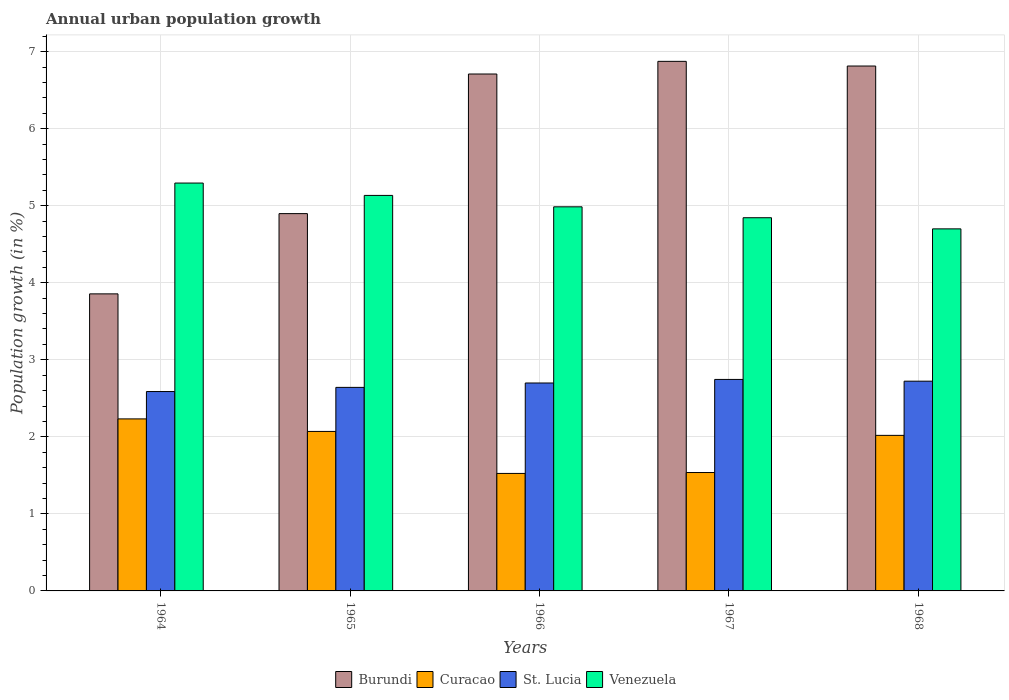Are the number of bars per tick equal to the number of legend labels?
Your answer should be very brief. Yes. Are the number of bars on each tick of the X-axis equal?
Offer a terse response. Yes. How many bars are there on the 1st tick from the left?
Ensure brevity in your answer.  4. What is the label of the 2nd group of bars from the left?
Make the answer very short. 1965. In how many cases, is the number of bars for a given year not equal to the number of legend labels?
Provide a short and direct response. 0. What is the percentage of urban population growth in Burundi in 1964?
Keep it short and to the point. 3.86. Across all years, what is the maximum percentage of urban population growth in Curacao?
Provide a succinct answer. 2.23. Across all years, what is the minimum percentage of urban population growth in St. Lucia?
Make the answer very short. 2.59. In which year was the percentage of urban population growth in St. Lucia maximum?
Ensure brevity in your answer.  1967. In which year was the percentage of urban population growth in Venezuela minimum?
Your response must be concise. 1968. What is the total percentage of urban population growth in Curacao in the graph?
Provide a short and direct response. 9.38. What is the difference between the percentage of urban population growth in Venezuela in 1964 and that in 1967?
Your response must be concise. 0.45. What is the difference between the percentage of urban population growth in Curacao in 1965 and the percentage of urban population growth in Venezuela in 1968?
Offer a very short reply. -2.63. What is the average percentage of urban population growth in Burundi per year?
Offer a terse response. 5.83. In the year 1965, what is the difference between the percentage of urban population growth in Burundi and percentage of urban population growth in Venezuela?
Make the answer very short. -0.24. In how many years, is the percentage of urban population growth in Curacao greater than 1.2 %?
Ensure brevity in your answer.  5. What is the ratio of the percentage of urban population growth in Curacao in 1964 to that in 1965?
Your answer should be compact. 1.08. What is the difference between the highest and the second highest percentage of urban population growth in St. Lucia?
Keep it short and to the point. 0.02. What is the difference between the highest and the lowest percentage of urban population growth in Curacao?
Your answer should be very brief. 0.71. What does the 2nd bar from the left in 1965 represents?
Provide a succinct answer. Curacao. What does the 3rd bar from the right in 1967 represents?
Keep it short and to the point. Curacao. Is it the case that in every year, the sum of the percentage of urban population growth in Burundi and percentage of urban population growth in Curacao is greater than the percentage of urban population growth in St. Lucia?
Provide a short and direct response. Yes. How many bars are there?
Give a very brief answer. 20. Are all the bars in the graph horizontal?
Your answer should be very brief. No. What is the difference between two consecutive major ticks on the Y-axis?
Your response must be concise. 1. Are the values on the major ticks of Y-axis written in scientific E-notation?
Your answer should be compact. No. How are the legend labels stacked?
Your answer should be very brief. Horizontal. What is the title of the graph?
Provide a short and direct response. Annual urban population growth. What is the label or title of the Y-axis?
Give a very brief answer. Population growth (in %). What is the Population growth (in %) of Burundi in 1964?
Give a very brief answer. 3.86. What is the Population growth (in %) of Curacao in 1964?
Your response must be concise. 2.23. What is the Population growth (in %) of St. Lucia in 1964?
Provide a short and direct response. 2.59. What is the Population growth (in %) of Venezuela in 1964?
Ensure brevity in your answer.  5.29. What is the Population growth (in %) of Burundi in 1965?
Your response must be concise. 4.9. What is the Population growth (in %) of Curacao in 1965?
Give a very brief answer. 2.07. What is the Population growth (in %) of St. Lucia in 1965?
Ensure brevity in your answer.  2.64. What is the Population growth (in %) of Venezuela in 1965?
Offer a terse response. 5.13. What is the Population growth (in %) in Burundi in 1966?
Ensure brevity in your answer.  6.71. What is the Population growth (in %) in Curacao in 1966?
Your response must be concise. 1.53. What is the Population growth (in %) of St. Lucia in 1966?
Your answer should be compact. 2.7. What is the Population growth (in %) in Venezuela in 1966?
Offer a terse response. 4.99. What is the Population growth (in %) of Burundi in 1967?
Provide a succinct answer. 6.87. What is the Population growth (in %) in Curacao in 1967?
Offer a terse response. 1.54. What is the Population growth (in %) of St. Lucia in 1967?
Provide a short and direct response. 2.75. What is the Population growth (in %) of Venezuela in 1967?
Your response must be concise. 4.84. What is the Population growth (in %) of Burundi in 1968?
Provide a short and direct response. 6.81. What is the Population growth (in %) in Curacao in 1968?
Your answer should be compact. 2.02. What is the Population growth (in %) in St. Lucia in 1968?
Provide a short and direct response. 2.72. What is the Population growth (in %) of Venezuela in 1968?
Give a very brief answer. 4.7. Across all years, what is the maximum Population growth (in %) in Burundi?
Offer a terse response. 6.87. Across all years, what is the maximum Population growth (in %) of Curacao?
Your response must be concise. 2.23. Across all years, what is the maximum Population growth (in %) of St. Lucia?
Provide a succinct answer. 2.75. Across all years, what is the maximum Population growth (in %) of Venezuela?
Your response must be concise. 5.29. Across all years, what is the minimum Population growth (in %) of Burundi?
Ensure brevity in your answer.  3.86. Across all years, what is the minimum Population growth (in %) in Curacao?
Provide a short and direct response. 1.53. Across all years, what is the minimum Population growth (in %) in St. Lucia?
Make the answer very short. 2.59. Across all years, what is the minimum Population growth (in %) of Venezuela?
Your response must be concise. 4.7. What is the total Population growth (in %) in Burundi in the graph?
Ensure brevity in your answer.  29.15. What is the total Population growth (in %) in Curacao in the graph?
Provide a short and direct response. 9.38. What is the total Population growth (in %) in St. Lucia in the graph?
Offer a terse response. 13.4. What is the total Population growth (in %) of Venezuela in the graph?
Your answer should be compact. 24.96. What is the difference between the Population growth (in %) in Burundi in 1964 and that in 1965?
Your answer should be compact. -1.04. What is the difference between the Population growth (in %) in Curacao in 1964 and that in 1965?
Keep it short and to the point. 0.16. What is the difference between the Population growth (in %) in St. Lucia in 1964 and that in 1965?
Provide a succinct answer. -0.05. What is the difference between the Population growth (in %) of Venezuela in 1964 and that in 1965?
Your response must be concise. 0.16. What is the difference between the Population growth (in %) in Burundi in 1964 and that in 1966?
Your answer should be very brief. -2.85. What is the difference between the Population growth (in %) in Curacao in 1964 and that in 1966?
Your answer should be very brief. 0.71. What is the difference between the Population growth (in %) in St. Lucia in 1964 and that in 1966?
Ensure brevity in your answer.  -0.11. What is the difference between the Population growth (in %) of Venezuela in 1964 and that in 1966?
Provide a succinct answer. 0.31. What is the difference between the Population growth (in %) of Burundi in 1964 and that in 1967?
Give a very brief answer. -3.02. What is the difference between the Population growth (in %) of Curacao in 1964 and that in 1967?
Give a very brief answer. 0.7. What is the difference between the Population growth (in %) in St. Lucia in 1964 and that in 1967?
Your response must be concise. -0.16. What is the difference between the Population growth (in %) in Venezuela in 1964 and that in 1967?
Your response must be concise. 0.45. What is the difference between the Population growth (in %) of Burundi in 1964 and that in 1968?
Give a very brief answer. -2.96. What is the difference between the Population growth (in %) of Curacao in 1964 and that in 1968?
Make the answer very short. 0.21. What is the difference between the Population growth (in %) in St. Lucia in 1964 and that in 1968?
Ensure brevity in your answer.  -0.13. What is the difference between the Population growth (in %) of Venezuela in 1964 and that in 1968?
Your answer should be very brief. 0.59. What is the difference between the Population growth (in %) in Burundi in 1965 and that in 1966?
Offer a very short reply. -1.81. What is the difference between the Population growth (in %) in Curacao in 1965 and that in 1966?
Give a very brief answer. 0.55. What is the difference between the Population growth (in %) in St. Lucia in 1965 and that in 1966?
Make the answer very short. -0.06. What is the difference between the Population growth (in %) in Venezuela in 1965 and that in 1966?
Make the answer very short. 0.15. What is the difference between the Population growth (in %) of Burundi in 1965 and that in 1967?
Offer a terse response. -1.98. What is the difference between the Population growth (in %) of Curacao in 1965 and that in 1967?
Offer a terse response. 0.53. What is the difference between the Population growth (in %) of St. Lucia in 1965 and that in 1967?
Make the answer very short. -0.1. What is the difference between the Population growth (in %) in Venezuela in 1965 and that in 1967?
Offer a terse response. 0.29. What is the difference between the Population growth (in %) of Burundi in 1965 and that in 1968?
Provide a succinct answer. -1.92. What is the difference between the Population growth (in %) of Curacao in 1965 and that in 1968?
Give a very brief answer. 0.05. What is the difference between the Population growth (in %) of St. Lucia in 1965 and that in 1968?
Ensure brevity in your answer.  -0.08. What is the difference between the Population growth (in %) of Venezuela in 1965 and that in 1968?
Your answer should be compact. 0.43. What is the difference between the Population growth (in %) of Burundi in 1966 and that in 1967?
Provide a short and direct response. -0.16. What is the difference between the Population growth (in %) of Curacao in 1966 and that in 1967?
Provide a short and direct response. -0.01. What is the difference between the Population growth (in %) in St. Lucia in 1966 and that in 1967?
Your answer should be compact. -0.05. What is the difference between the Population growth (in %) in Venezuela in 1966 and that in 1967?
Your answer should be compact. 0.14. What is the difference between the Population growth (in %) in Burundi in 1966 and that in 1968?
Make the answer very short. -0.1. What is the difference between the Population growth (in %) of Curacao in 1966 and that in 1968?
Offer a terse response. -0.49. What is the difference between the Population growth (in %) in St. Lucia in 1966 and that in 1968?
Your answer should be very brief. -0.02. What is the difference between the Population growth (in %) of Venezuela in 1966 and that in 1968?
Offer a very short reply. 0.29. What is the difference between the Population growth (in %) in Burundi in 1967 and that in 1968?
Keep it short and to the point. 0.06. What is the difference between the Population growth (in %) in Curacao in 1967 and that in 1968?
Give a very brief answer. -0.48. What is the difference between the Population growth (in %) in St. Lucia in 1967 and that in 1968?
Make the answer very short. 0.02. What is the difference between the Population growth (in %) in Venezuela in 1967 and that in 1968?
Make the answer very short. 0.14. What is the difference between the Population growth (in %) of Burundi in 1964 and the Population growth (in %) of Curacao in 1965?
Make the answer very short. 1.79. What is the difference between the Population growth (in %) in Burundi in 1964 and the Population growth (in %) in St. Lucia in 1965?
Offer a terse response. 1.21. What is the difference between the Population growth (in %) in Burundi in 1964 and the Population growth (in %) in Venezuela in 1965?
Your answer should be compact. -1.28. What is the difference between the Population growth (in %) of Curacao in 1964 and the Population growth (in %) of St. Lucia in 1965?
Offer a very short reply. -0.41. What is the difference between the Population growth (in %) of Curacao in 1964 and the Population growth (in %) of Venezuela in 1965?
Give a very brief answer. -2.9. What is the difference between the Population growth (in %) of St. Lucia in 1964 and the Population growth (in %) of Venezuela in 1965?
Give a very brief answer. -2.55. What is the difference between the Population growth (in %) in Burundi in 1964 and the Population growth (in %) in Curacao in 1966?
Keep it short and to the point. 2.33. What is the difference between the Population growth (in %) of Burundi in 1964 and the Population growth (in %) of St. Lucia in 1966?
Give a very brief answer. 1.16. What is the difference between the Population growth (in %) in Burundi in 1964 and the Population growth (in %) in Venezuela in 1966?
Give a very brief answer. -1.13. What is the difference between the Population growth (in %) of Curacao in 1964 and the Population growth (in %) of St. Lucia in 1966?
Offer a terse response. -0.47. What is the difference between the Population growth (in %) in Curacao in 1964 and the Population growth (in %) in Venezuela in 1966?
Give a very brief answer. -2.75. What is the difference between the Population growth (in %) in St. Lucia in 1964 and the Population growth (in %) in Venezuela in 1966?
Keep it short and to the point. -2.4. What is the difference between the Population growth (in %) of Burundi in 1964 and the Population growth (in %) of Curacao in 1967?
Your answer should be compact. 2.32. What is the difference between the Population growth (in %) of Burundi in 1964 and the Population growth (in %) of St. Lucia in 1967?
Ensure brevity in your answer.  1.11. What is the difference between the Population growth (in %) in Burundi in 1964 and the Population growth (in %) in Venezuela in 1967?
Give a very brief answer. -0.99. What is the difference between the Population growth (in %) in Curacao in 1964 and the Population growth (in %) in St. Lucia in 1967?
Your answer should be compact. -0.51. What is the difference between the Population growth (in %) of Curacao in 1964 and the Population growth (in %) of Venezuela in 1967?
Give a very brief answer. -2.61. What is the difference between the Population growth (in %) of St. Lucia in 1964 and the Population growth (in %) of Venezuela in 1967?
Your answer should be very brief. -2.26. What is the difference between the Population growth (in %) of Burundi in 1964 and the Population growth (in %) of Curacao in 1968?
Give a very brief answer. 1.84. What is the difference between the Population growth (in %) of Burundi in 1964 and the Population growth (in %) of St. Lucia in 1968?
Give a very brief answer. 1.13. What is the difference between the Population growth (in %) of Burundi in 1964 and the Population growth (in %) of Venezuela in 1968?
Offer a terse response. -0.84. What is the difference between the Population growth (in %) in Curacao in 1964 and the Population growth (in %) in St. Lucia in 1968?
Keep it short and to the point. -0.49. What is the difference between the Population growth (in %) in Curacao in 1964 and the Population growth (in %) in Venezuela in 1968?
Make the answer very short. -2.47. What is the difference between the Population growth (in %) in St. Lucia in 1964 and the Population growth (in %) in Venezuela in 1968?
Your answer should be very brief. -2.11. What is the difference between the Population growth (in %) in Burundi in 1965 and the Population growth (in %) in Curacao in 1966?
Offer a terse response. 3.37. What is the difference between the Population growth (in %) in Burundi in 1965 and the Population growth (in %) in St. Lucia in 1966?
Provide a succinct answer. 2.2. What is the difference between the Population growth (in %) of Burundi in 1965 and the Population growth (in %) of Venezuela in 1966?
Your answer should be compact. -0.09. What is the difference between the Population growth (in %) of Curacao in 1965 and the Population growth (in %) of St. Lucia in 1966?
Ensure brevity in your answer.  -0.63. What is the difference between the Population growth (in %) of Curacao in 1965 and the Population growth (in %) of Venezuela in 1966?
Your response must be concise. -2.92. What is the difference between the Population growth (in %) of St. Lucia in 1965 and the Population growth (in %) of Venezuela in 1966?
Make the answer very short. -2.34. What is the difference between the Population growth (in %) of Burundi in 1965 and the Population growth (in %) of Curacao in 1967?
Ensure brevity in your answer.  3.36. What is the difference between the Population growth (in %) in Burundi in 1965 and the Population growth (in %) in St. Lucia in 1967?
Provide a succinct answer. 2.15. What is the difference between the Population growth (in %) of Burundi in 1965 and the Population growth (in %) of Venezuela in 1967?
Give a very brief answer. 0.05. What is the difference between the Population growth (in %) of Curacao in 1965 and the Population growth (in %) of St. Lucia in 1967?
Your response must be concise. -0.68. What is the difference between the Population growth (in %) in Curacao in 1965 and the Population growth (in %) in Venezuela in 1967?
Provide a succinct answer. -2.77. What is the difference between the Population growth (in %) in St. Lucia in 1965 and the Population growth (in %) in Venezuela in 1967?
Offer a terse response. -2.2. What is the difference between the Population growth (in %) in Burundi in 1965 and the Population growth (in %) in Curacao in 1968?
Keep it short and to the point. 2.88. What is the difference between the Population growth (in %) in Burundi in 1965 and the Population growth (in %) in St. Lucia in 1968?
Provide a short and direct response. 2.17. What is the difference between the Population growth (in %) of Burundi in 1965 and the Population growth (in %) of Venezuela in 1968?
Make the answer very short. 0.2. What is the difference between the Population growth (in %) of Curacao in 1965 and the Population growth (in %) of St. Lucia in 1968?
Provide a short and direct response. -0.65. What is the difference between the Population growth (in %) of Curacao in 1965 and the Population growth (in %) of Venezuela in 1968?
Provide a succinct answer. -2.63. What is the difference between the Population growth (in %) of St. Lucia in 1965 and the Population growth (in %) of Venezuela in 1968?
Provide a succinct answer. -2.06. What is the difference between the Population growth (in %) in Burundi in 1966 and the Population growth (in %) in Curacao in 1967?
Your answer should be compact. 5.17. What is the difference between the Population growth (in %) in Burundi in 1966 and the Population growth (in %) in St. Lucia in 1967?
Keep it short and to the point. 3.96. What is the difference between the Population growth (in %) in Burundi in 1966 and the Population growth (in %) in Venezuela in 1967?
Offer a terse response. 1.87. What is the difference between the Population growth (in %) in Curacao in 1966 and the Population growth (in %) in St. Lucia in 1967?
Offer a terse response. -1.22. What is the difference between the Population growth (in %) of Curacao in 1966 and the Population growth (in %) of Venezuela in 1967?
Your answer should be very brief. -3.32. What is the difference between the Population growth (in %) of St. Lucia in 1966 and the Population growth (in %) of Venezuela in 1967?
Provide a succinct answer. -2.15. What is the difference between the Population growth (in %) of Burundi in 1966 and the Population growth (in %) of Curacao in 1968?
Your response must be concise. 4.69. What is the difference between the Population growth (in %) of Burundi in 1966 and the Population growth (in %) of St. Lucia in 1968?
Offer a terse response. 3.99. What is the difference between the Population growth (in %) of Burundi in 1966 and the Population growth (in %) of Venezuela in 1968?
Give a very brief answer. 2.01. What is the difference between the Population growth (in %) of Curacao in 1966 and the Population growth (in %) of St. Lucia in 1968?
Your answer should be very brief. -1.2. What is the difference between the Population growth (in %) of Curacao in 1966 and the Population growth (in %) of Venezuela in 1968?
Provide a short and direct response. -3.17. What is the difference between the Population growth (in %) in St. Lucia in 1966 and the Population growth (in %) in Venezuela in 1968?
Your response must be concise. -2. What is the difference between the Population growth (in %) in Burundi in 1967 and the Population growth (in %) in Curacao in 1968?
Make the answer very short. 4.86. What is the difference between the Population growth (in %) in Burundi in 1967 and the Population growth (in %) in St. Lucia in 1968?
Keep it short and to the point. 4.15. What is the difference between the Population growth (in %) in Burundi in 1967 and the Population growth (in %) in Venezuela in 1968?
Keep it short and to the point. 2.17. What is the difference between the Population growth (in %) in Curacao in 1967 and the Population growth (in %) in St. Lucia in 1968?
Your answer should be very brief. -1.19. What is the difference between the Population growth (in %) of Curacao in 1967 and the Population growth (in %) of Venezuela in 1968?
Make the answer very short. -3.16. What is the difference between the Population growth (in %) of St. Lucia in 1967 and the Population growth (in %) of Venezuela in 1968?
Provide a succinct answer. -1.95. What is the average Population growth (in %) of Burundi per year?
Your answer should be very brief. 5.83. What is the average Population growth (in %) of Curacao per year?
Offer a terse response. 1.88. What is the average Population growth (in %) in St. Lucia per year?
Keep it short and to the point. 2.68. What is the average Population growth (in %) of Venezuela per year?
Ensure brevity in your answer.  4.99. In the year 1964, what is the difference between the Population growth (in %) of Burundi and Population growth (in %) of Curacao?
Provide a succinct answer. 1.62. In the year 1964, what is the difference between the Population growth (in %) in Burundi and Population growth (in %) in St. Lucia?
Give a very brief answer. 1.27. In the year 1964, what is the difference between the Population growth (in %) in Burundi and Population growth (in %) in Venezuela?
Your answer should be very brief. -1.44. In the year 1964, what is the difference between the Population growth (in %) in Curacao and Population growth (in %) in St. Lucia?
Your answer should be compact. -0.36. In the year 1964, what is the difference between the Population growth (in %) of Curacao and Population growth (in %) of Venezuela?
Provide a short and direct response. -3.06. In the year 1964, what is the difference between the Population growth (in %) of St. Lucia and Population growth (in %) of Venezuela?
Make the answer very short. -2.71. In the year 1965, what is the difference between the Population growth (in %) in Burundi and Population growth (in %) in Curacao?
Provide a short and direct response. 2.83. In the year 1965, what is the difference between the Population growth (in %) of Burundi and Population growth (in %) of St. Lucia?
Make the answer very short. 2.26. In the year 1965, what is the difference between the Population growth (in %) in Burundi and Population growth (in %) in Venezuela?
Provide a short and direct response. -0.24. In the year 1965, what is the difference between the Population growth (in %) in Curacao and Population growth (in %) in St. Lucia?
Your answer should be very brief. -0.57. In the year 1965, what is the difference between the Population growth (in %) in Curacao and Population growth (in %) in Venezuela?
Your answer should be compact. -3.06. In the year 1965, what is the difference between the Population growth (in %) in St. Lucia and Population growth (in %) in Venezuela?
Ensure brevity in your answer.  -2.49. In the year 1966, what is the difference between the Population growth (in %) in Burundi and Population growth (in %) in Curacao?
Provide a short and direct response. 5.18. In the year 1966, what is the difference between the Population growth (in %) of Burundi and Population growth (in %) of St. Lucia?
Make the answer very short. 4.01. In the year 1966, what is the difference between the Population growth (in %) in Burundi and Population growth (in %) in Venezuela?
Keep it short and to the point. 1.72. In the year 1966, what is the difference between the Population growth (in %) in Curacao and Population growth (in %) in St. Lucia?
Provide a short and direct response. -1.17. In the year 1966, what is the difference between the Population growth (in %) of Curacao and Population growth (in %) of Venezuela?
Provide a succinct answer. -3.46. In the year 1966, what is the difference between the Population growth (in %) in St. Lucia and Population growth (in %) in Venezuela?
Give a very brief answer. -2.29. In the year 1967, what is the difference between the Population growth (in %) in Burundi and Population growth (in %) in Curacao?
Your answer should be very brief. 5.34. In the year 1967, what is the difference between the Population growth (in %) in Burundi and Population growth (in %) in St. Lucia?
Make the answer very short. 4.13. In the year 1967, what is the difference between the Population growth (in %) in Burundi and Population growth (in %) in Venezuela?
Your response must be concise. 2.03. In the year 1967, what is the difference between the Population growth (in %) of Curacao and Population growth (in %) of St. Lucia?
Offer a terse response. -1.21. In the year 1967, what is the difference between the Population growth (in %) in Curacao and Population growth (in %) in Venezuela?
Keep it short and to the point. -3.31. In the year 1967, what is the difference between the Population growth (in %) of St. Lucia and Population growth (in %) of Venezuela?
Your response must be concise. -2.1. In the year 1968, what is the difference between the Population growth (in %) of Burundi and Population growth (in %) of Curacao?
Give a very brief answer. 4.79. In the year 1968, what is the difference between the Population growth (in %) in Burundi and Population growth (in %) in St. Lucia?
Provide a succinct answer. 4.09. In the year 1968, what is the difference between the Population growth (in %) in Burundi and Population growth (in %) in Venezuela?
Your response must be concise. 2.11. In the year 1968, what is the difference between the Population growth (in %) of Curacao and Population growth (in %) of St. Lucia?
Provide a succinct answer. -0.7. In the year 1968, what is the difference between the Population growth (in %) in Curacao and Population growth (in %) in Venezuela?
Provide a short and direct response. -2.68. In the year 1968, what is the difference between the Population growth (in %) in St. Lucia and Population growth (in %) in Venezuela?
Keep it short and to the point. -1.98. What is the ratio of the Population growth (in %) in Burundi in 1964 to that in 1965?
Your response must be concise. 0.79. What is the ratio of the Population growth (in %) in Curacao in 1964 to that in 1965?
Offer a terse response. 1.08. What is the ratio of the Population growth (in %) in St. Lucia in 1964 to that in 1965?
Provide a short and direct response. 0.98. What is the ratio of the Population growth (in %) of Venezuela in 1964 to that in 1965?
Offer a terse response. 1.03. What is the ratio of the Population growth (in %) in Burundi in 1964 to that in 1966?
Make the answer very short. 0.57. What is the ratio of the Population growth (in %) of Curacao in 1964 to that in 1966?
Offer a very short reply. 1.46. What is the ratio of the Population growth (in %) of St. Lucia in 1964 to that in 1966?
Provide a short and direct response. 0.96. What is the ratio of the Population growth (in %) of Venezuela in 1964 to that in 1966?
Your answer should be very brief. 1.06. What is the ratio of the Population growth (in %) in Burundi in 1964 to that in 1967?
Your answer should be compact. 0.56. What is the ratio of the Population growth (in %) in Curacao in 1964 to that in 1967?
Offer a terse response. 1.45. What is the ratio of the Population growth (in %) of St. Lucia in 1964 to that in 1967?
Your answer should be very brief. 0.94. What is the ratio of the Population growth (in %) in Venezuela in 1964 to that in 1967?
Offer a terse response. 1.09. What is the ratio of the Population growth (in %) in Burundi in 1964 to that in 1968?
Provide a short and direct response. 0.57. What is the ratio of the Population growth (in %) of Curacao in 1964 to that in 1968?
Ensure brevity in your answer.  1.11. What is the ratio of the Population growth (in %) in St. Lucia in 1964 to that in 1968?
Ensure brevity in your answer.  0.95. What is the ratio of the Population growth (in %) of Venezuela in 1964 to that in 1968?
Offer a terse response. 1.13. What is the ratio of the Population growth (in %) in Burundi in 1965 to that in 1966?
Give a very brief answer. 0.73. What is the ratio of the Population growth (in %) in Curacao in 1965 to that in 1966?
Ensure brevity in your answer.  1.36. What is the ratio of the Population growth (in %) in St. Lucia in 1965 to that in 1966?
Keep it short and to the point. 0.98. What is the ratio of the Population growth (in %) in Venezuela in 1965 to that in 1966?
Make the answer very short. 1.03. What is the ratio of the Population growth (in %) in Burundi in 1965 to that in 1967?
Make the answer very short. 0.71. What is the ratio of the Population growth (in %) in Curacao in 1965 to that in 1967?
Provide a short and direct response. 1.35. What is the ratio of the Population growth (in %) of St. Lucia in 1965 to that in 1967?
Keep it short and to the point. 0.96. What is the ratio of the Population growth (in %) in Venezuela in 1965 to that in 1967?
Your answer should be compact. 1.06. What is the ratio of the Population growth (in %) of Burundi in 1965 to that in 1968?
Your answer should be compact. 0.72. What is the ratio of the Population growth (in %) in Curacao in 1965 to that in 1968?
Make the answer very short. 1.03. What is the ratio of the Population growth (in %) of St. Lucia in 1965 to that in 1968?
Ensure brevity in your answer.  0.97. What is the ratio of the Population growth (in %) of Venezuela in 1965 to that in 1968?
Make the answer very short. 1.09. What is the ratio of the Population growth (in %) of Burundi in 1966 to that in 1967?
Your response must be concise. 0.98. What is the ratio of the Population growth (in %) in Curacao in 1966 to that in 1967?
Your answer should be very brief. 0.99. What is the ratio of the Population growth (in %) in St. Lucia in 1966 to that in 1967?
Your answer should be very brief. 0.98. What is the ratio of the Population growth (in %) of Venezuela in 1966 to that in 1967?
Give a very brief answer. 1.03. What is the ratio of the Population growth (in %) in Burundi in 1966 to that in 1968?
Your response must be concise. 0.98. What is the ratio of the Population growth (in %) of Curacao in 1966 to that in 1968?
Keep it short and to the point. 0.76. What is the ratio of the Population growth (in %) of St. Lucia in 1966 to that in 1968?
Offer a terse response. 0.99. What is the ratio of the Population growth (in %) of Venezuela in 1966 to that in 1968?
Keep it short and to the point. 1.06. What is the ratio of the Population growth (in %) in Burundi in 1967 to that in 1968?
Your answer should be compact. 1.01. What is the ratio of the Population growth (in %) in Curacao in 1967 to that in 1968?
Ensure brevity in your answer.  0.76. What is the ratio of the Population growth (in %) in St. Lucia in 1967 to that in 1968?
Provide a succinct answer. 1.01. What is the ratio of the Population growth (in %) of Venezuela in 1967 to that in 1968?
Offer a very short reply. 1.03. What is the difference between the highest and the second highest Population growth (in %) in Burundi?
Offer a very short reply. 0.06. What is the difference between the highest and the second highest Population growth (in %) in Curacao?
Your answer should be very brief. 0.16. What is the difference between the highest and the second highest Population growth (in %) in St. Lucia?
Ensure brevity in your answer.  0.02. What is the difference between the highest and the second highest Population growth (in %) in Venezuela?
Give a very brief answer. 0.16. What is the difference between the highest and the lowest Population growth (in %) in Burundi?
Offer a terse response. 3.02. What is the difference between the highest and the lowest Population growth (in %) of Curacao?
Make the answer very short. 0.71. What is the difference between the highest and the lowest Population growth (in %) of St. Lucia?
Your response must be concise. 0.16. What is the difference between the highest and the lowest Population growth (in %) in Venezuela?
Offer a terse response. 0.59. 